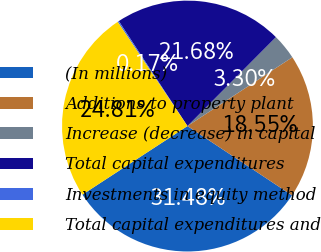Convert chart to OTSL. <chart><loc_0><loc_0><loc_500><loc_500><pie_chart><fcel>(In millions)<fcel>Additions to property plant<fcel>Increase (decrease) in capital<fcel>Total capital expenditures<fcel>Investments in equity method<fcel>Total capital expenditures and<nl><fcel>31.48%<fcel>18.55%<fcel>3.3%<fcel>21.68%<fcel>0.17%<fcel>24.81%<nl></chart> 